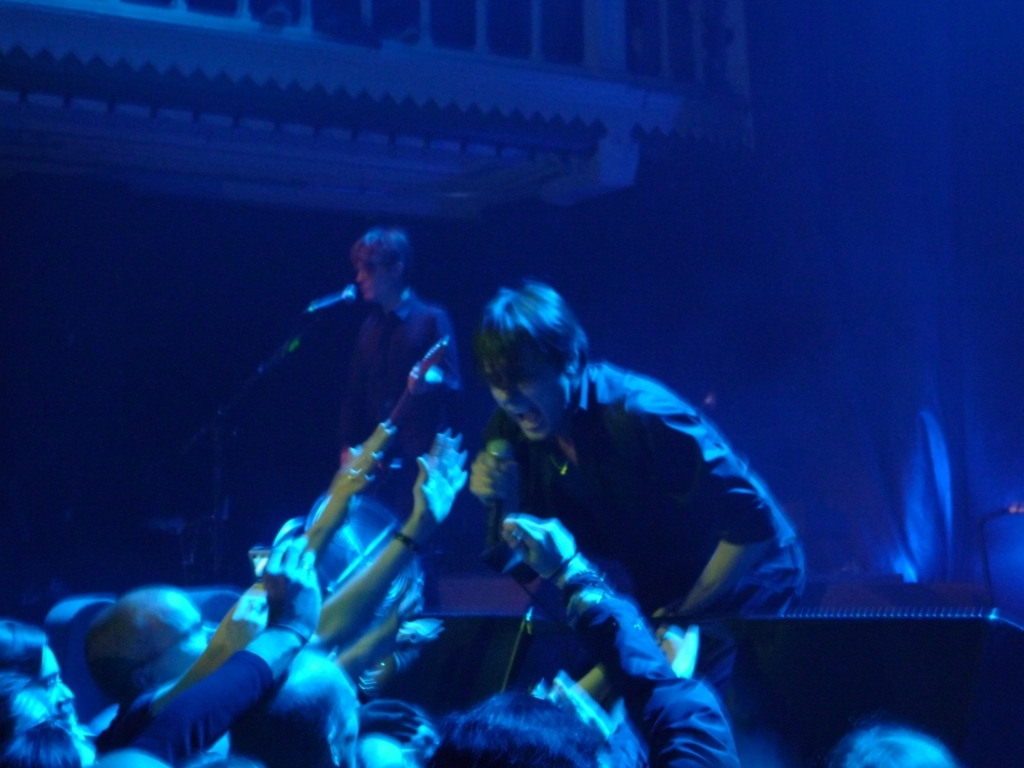Is the color tone of the image warm? The image conveys a cooler tone, characterized by the dominance of blues and purples in the lighting. While there's a hint of warmer hues towards the bottom right, they're not sufficient to overall classify the image as having a warm tone. 